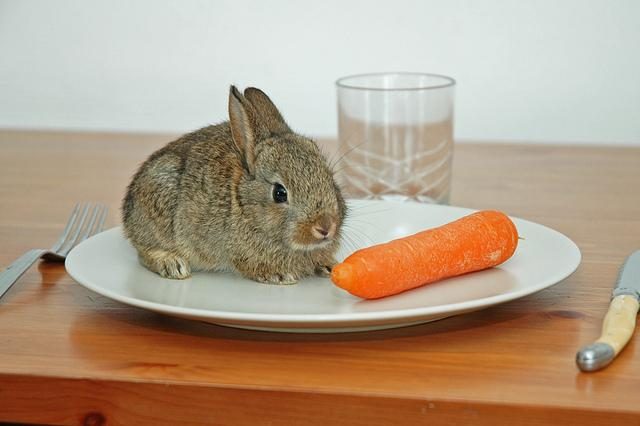What is the rabbit doing on the plate?

Choices:
A) mating
B) playing
C) sleeping
D) eating carrot eating carrot 